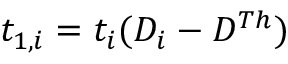Convert formula to latex. <formula><loc_0><loc_0><loc_500><loc_500>t _ { 1 , i } = t _ { i } ( D _ { i } - D ^ { T h } )</formula> 